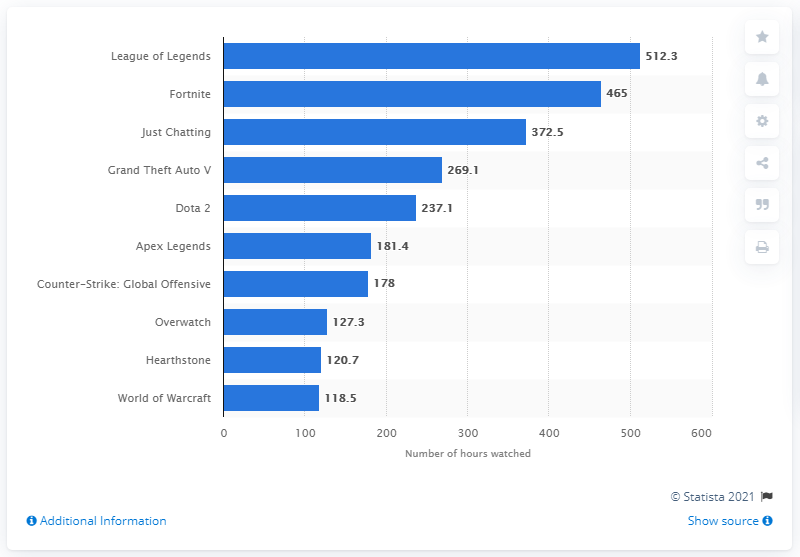Outline some significant characteristics in this image. In the first half of 2019, League of Legends viewership on Twitch totaled 512.3 hours. League of Legends, a popular multiplayer online battle arena game, topped the charts with an astonishing 512.3 million hours watched on Twitch in the first half of 2019. 